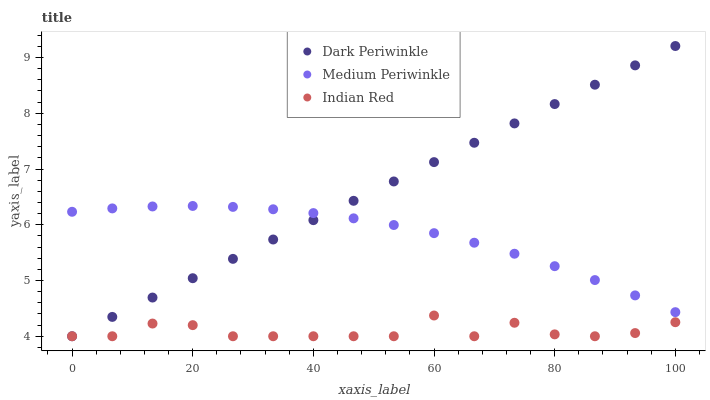Does Indian Red have the minimum area under the curve?
Answer yes or no. Yes. Does Dark Periwinkle have the maximum area under the curve?
Answer yes or no. Yes. Does Dark Periwinkle have the minimum area under the curve?
Answer yes or no. No. Does Indian Red have the maximum area under the curve?
Answer yes or no. No. Is Dark Periwinkle the smoothest?
Answer yes or no. Yes. Is Indian Red the roughest?
Answer yes or no. Yes. Is Indian Red the smoothest?
Answer yes or no. No. Is Dark Periwinkle the roughest?
Answer yes or no. No. Does Dark Periwinkle have the lowest value?
Answer yes or no. Yes. Does Dark Periwinkle have the highest value?
Answer yes or no. Yes. Does Indian Red have the highest value?
Answer yes or no. No. Is Indian Red less than Medium Periwinkle?
Answer yes or no. Yes. Is Medium Periwinkle greater than Indian Red?
Answer yes or no. Yes. Does Medium Periwinkle intersect Dark Periwinkle?
Answer yes or no. Yes. Is Medium Periwinkle less than Dark Periwinkle?
Answer yes or no. No. Is Medium Periwinkle greater than Dark Periwinkle?
Answer yes or no. No. Does Indian Red intersect Medium Periwinkle?
Answer yes or no. No. 